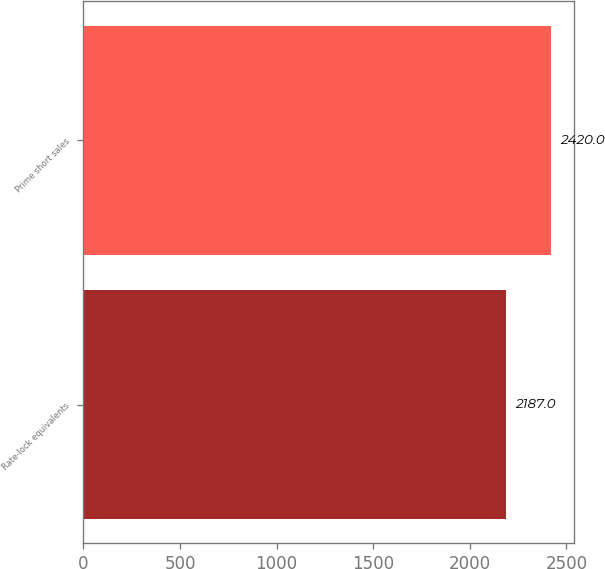Convert chart. <chart><loc_0><loc_0><loc_500><loc_500><bar_chart><fcel>Rate-lock equivalents<fcel>Prime short sales<nl><fcel>2187<fcel>2420<nl></chart> 